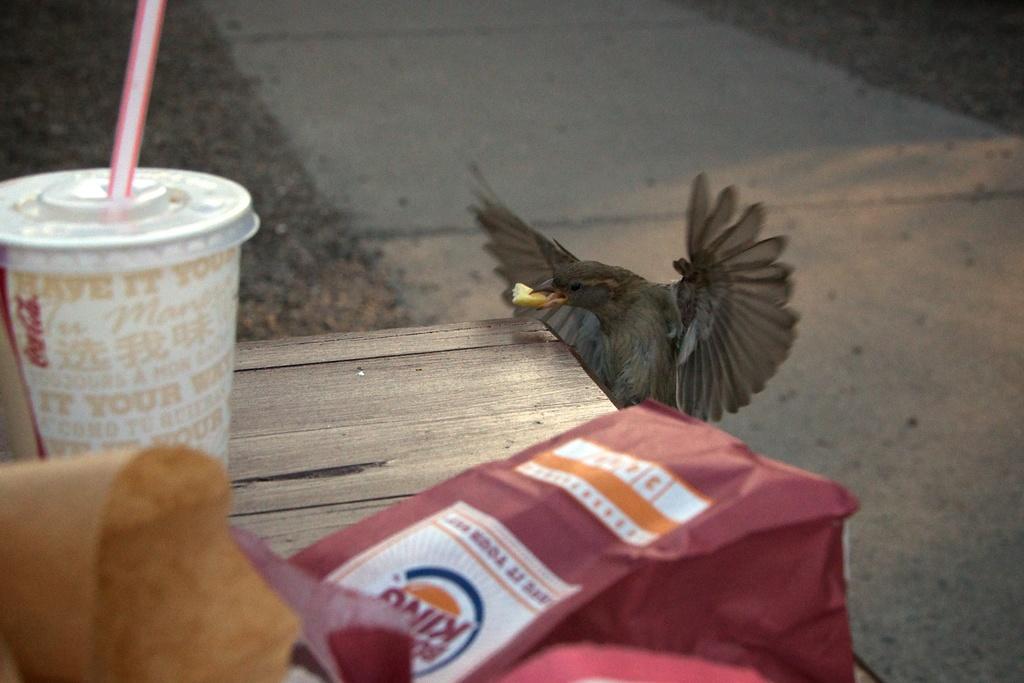Please provide a concise description of this image. In this picture, there is a paper bag which is in red in color is at the bottom. Behind it, there is a bird which is in grey in color. Towards the left, there is a glass with a straw. All the objects are placed on the table. Towards the right, there is a lane. 